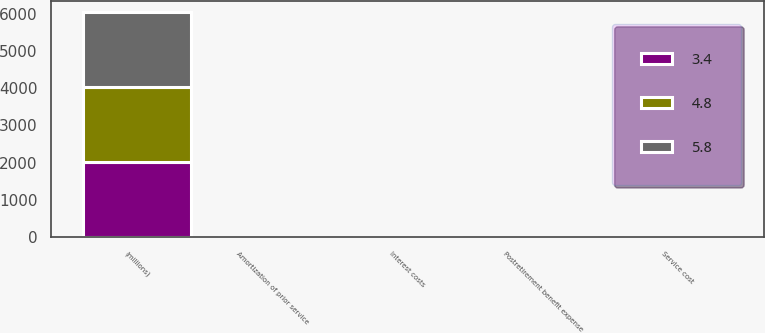<chart> <loc_0><loc_0><loc_500><loc_500><stacked_bar_chart><ecel><fcel>(millions)<fcel>Service cost<fcel>Interest costs<fcel>Amortization of prior service<fcel>Postretirement benefit expense<nl><fcel>3.4<fcel>2012<fcel>4<fcel>4.9<fcel>4<fcel>4.8<nl><fcel>5.8<fcel>2011<fcel>3.8<fcel>4.5<fcel>5.9<fcel>3.4<nl><fcel>4.8<fcel>2010<fcel>5<fcel>5<fcel>5.5<fcel>5.8<nl></chart> 